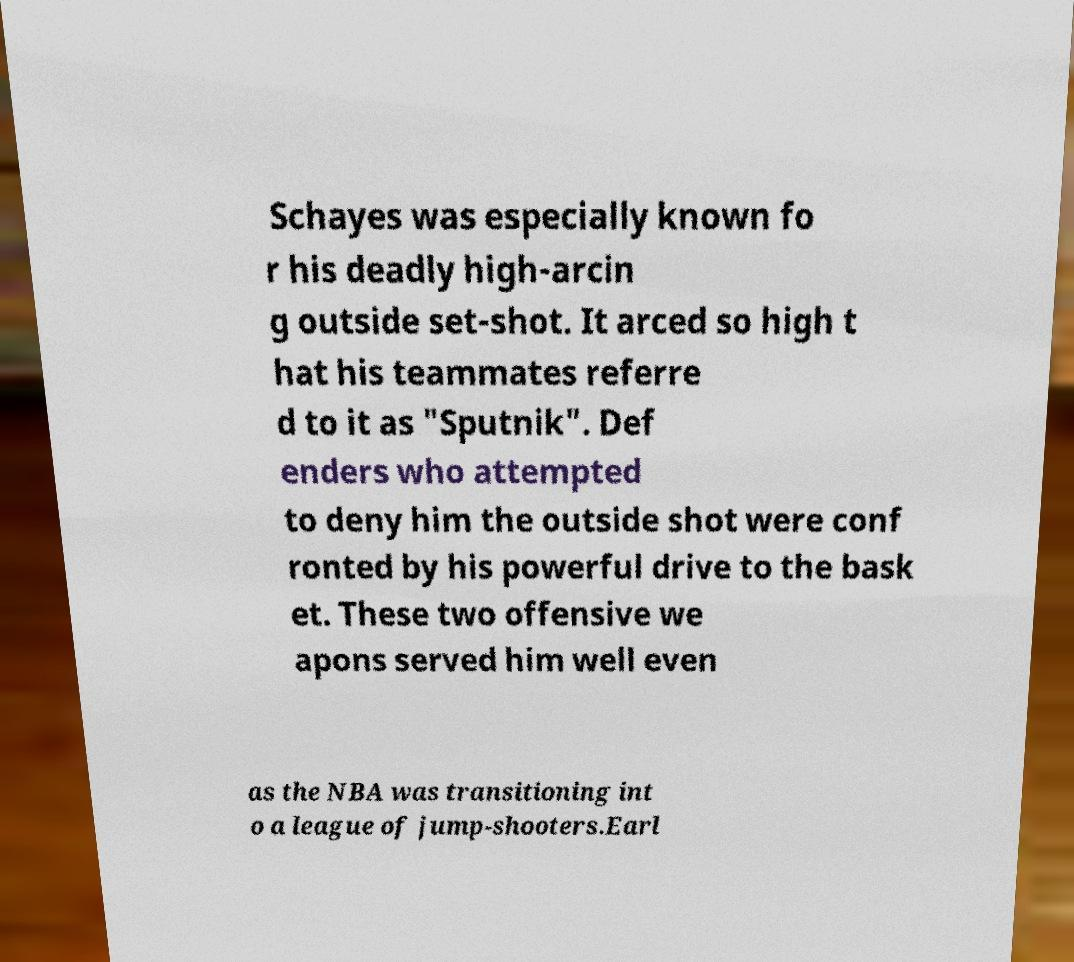What messages or text are displayed in this image? I need them in a readable, typed format. Schayes was especially known fo r his deadly high-arcin g outside set-shot. It arced so high t hat his teammates referre d to it as "Sputnik". Def enders who attempted to deny him the outside shot were conf ronted by his powerful drive to the bask et. These two offensive we apons served him well even as the NBA was transitioning int o a league of jump-shooters.Earl 